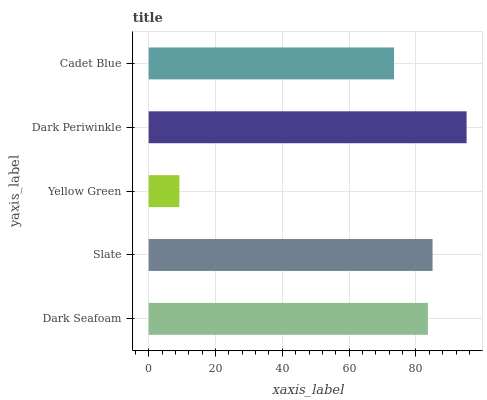Is Yellow Green the minimum?
Answer yes or no. Yes. Is Dark Periwinkle the maximum?
Answer yes or no. Yes. Is Slate the minimum?
Answer yes or no. No. Is Slate the maximum?
Answer yes or no. No. Is Slate greater than Dark Seafoam?
Answer yes or no. Yes. Is Dark Seafoam less than Slate?
Answer yes or no. Yes. Is Dark Seafoam greater than Slate?
Answer yes or no. No. Is Slate less than Dark Seafoam?
Answer yes or no. No. Is Dark Seafoam the high median?
Answer yes or no. Yes. Is Dark Seafoam the low median?
Answer yes or no. Yes. Is Dark Periwinkle the high median?
Answer yes or no. No. Is Slate the low median?
Answer yes or no. No. 